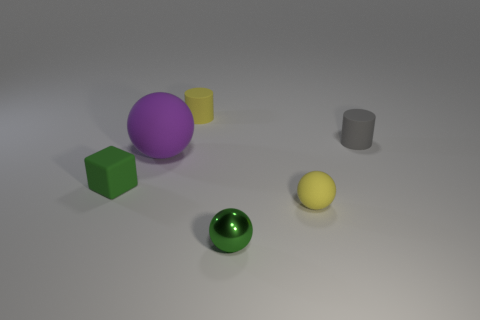Add 2 big yellow matte things. How many objects exist? 8 Subtract all cylinders. How many objects are left? 4 Add 2 tiny gray cylinders. How many tiny gray cylinders exist? 3 Subtract 1 yellow balls. How many objects are left? 5 Subtract all small green blocks. Subtract all green spheres. How many objects are left? 4 Add 4 small rubber balls. How many small rubber balls are left? 5 